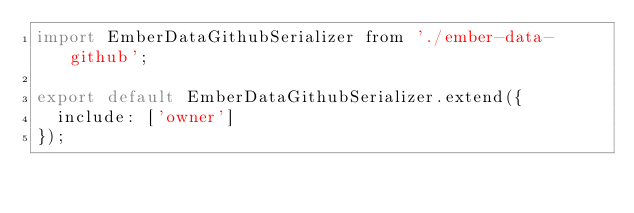<code> <loc_0><loc_0><loc_500><loc_500><_JavaScript_>import EmberDataGithubSerializer from './ember-data-github';

export default EmberDataGithubSerializer.extend({
  include: ['owner']
});
</code> 